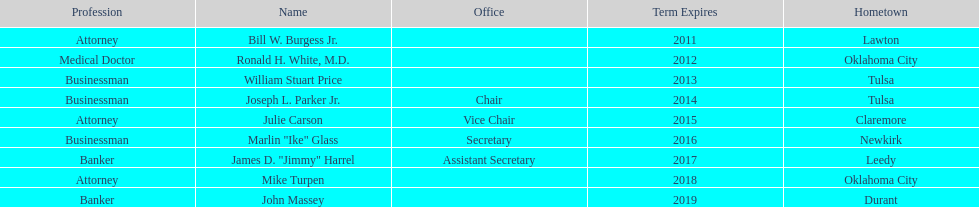What is the total number of state regents who are attorneys? 3. 